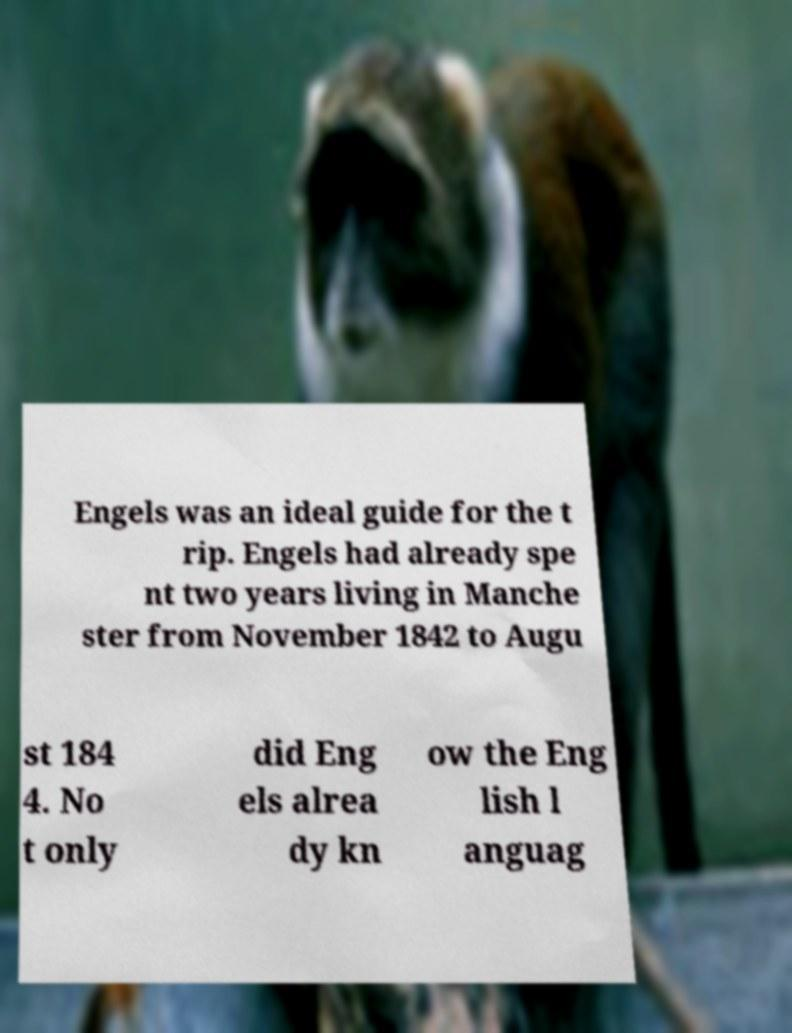I need the written content from this picture converted into text. Can you do that? Engels was an ideal guide for the t rip. Engels had already spe nt two years living in Manche ster from November 1842 to Augu st 184 4. No t only did Eng els alrea dy kn ow the Eng lish l anguag 